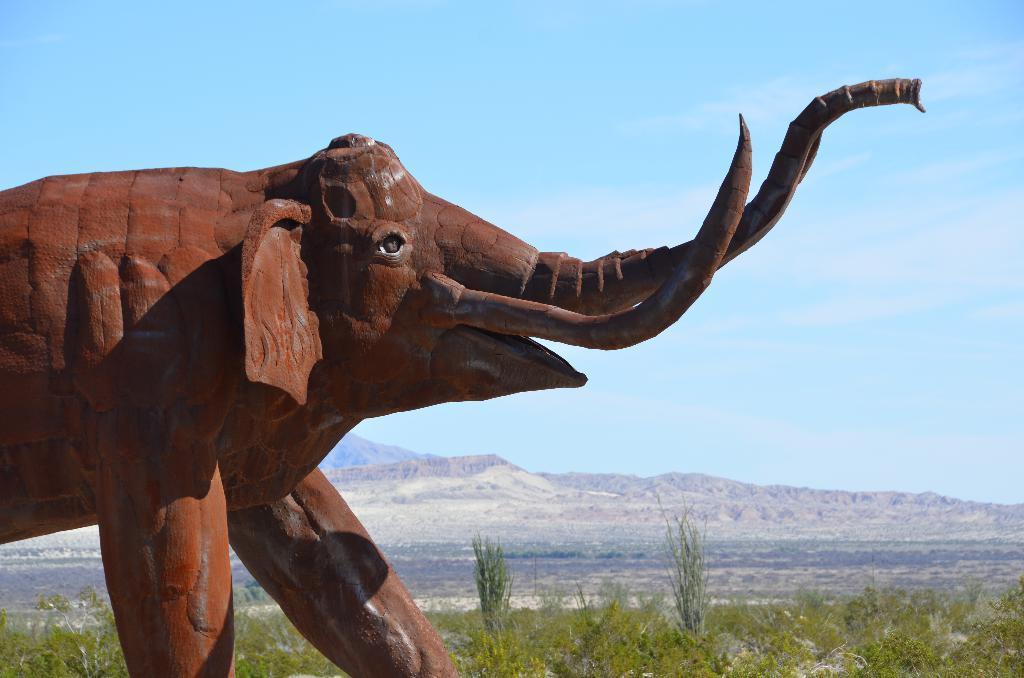In one or two sentences, can you explain what this image depicts? In this picture I can see a sculpture of an elephant, there are plants, trees, there are hills, and in the background there is the sky. 